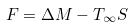Convert formula to latex. <formula><loc_0><loc_0><loc_500><loc_500>F = \Delta M - T _ { \infty } S</formula> 